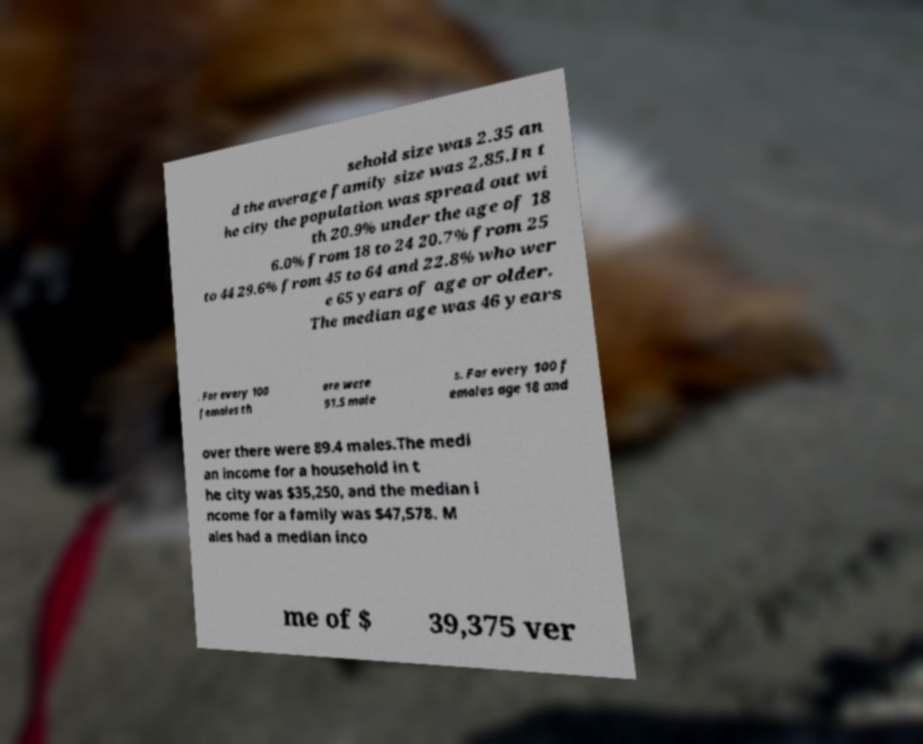Can you accurately transcribe the text from the provided image for me? sehold size was 2.35 an d the average family size was 2.85.In t he city the population was spread out wi th 20.9% under the age of 18 6.0% from 18 to 24 20.7% from 25 to 44 29.6% from 45 to 64 and 22.8% who wer e 65 years of age or older. The median age was 46 years . For every 100 females th ere were 91.5 male s. For every 100 f emales age 18 and over there were 89.4 males.The medi an income for a household in t he city was $35,250, and the median i ncome for a family was $47,578. M ales had a median inco me of $ 39,375 ver 